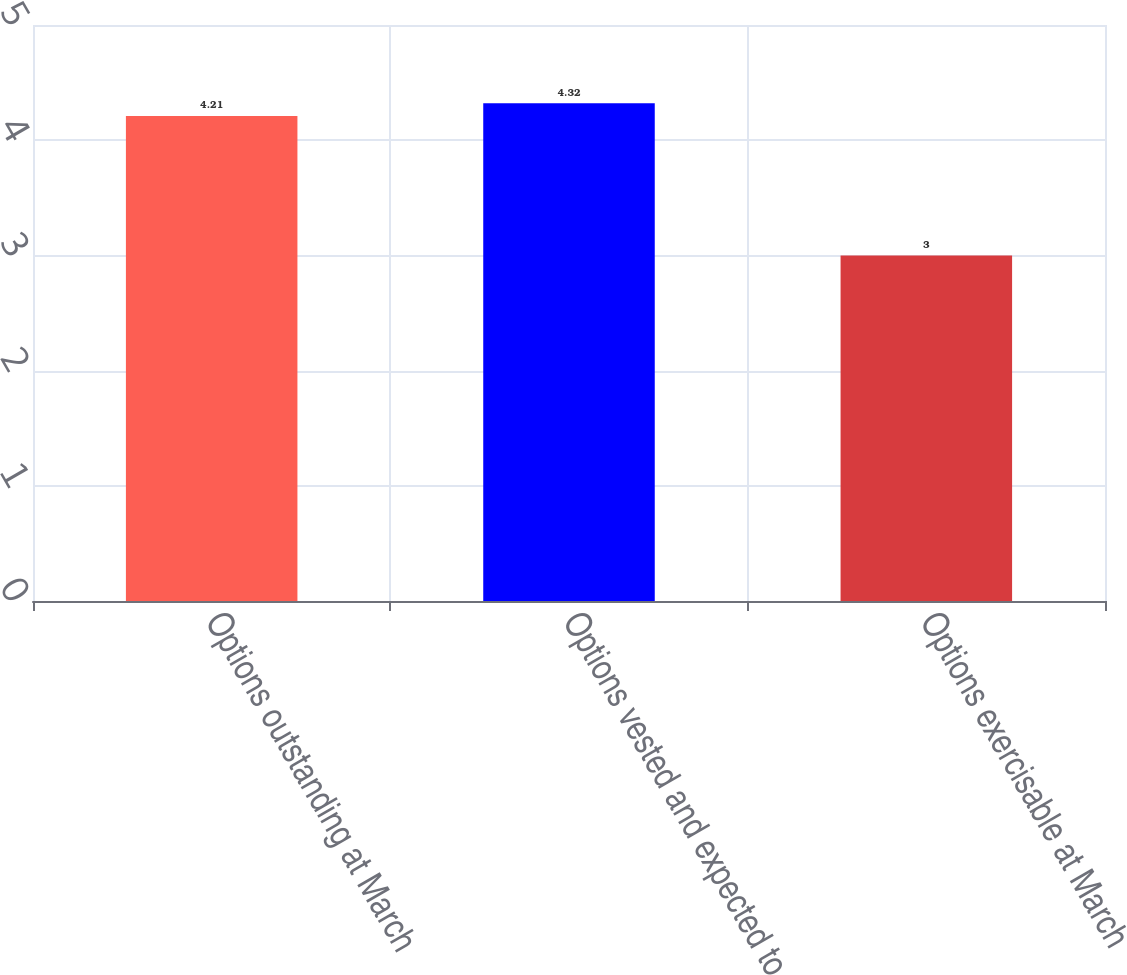Convert chart. <chart><loc_0><loc_0><loc_500><loc_500><bar_chart><fcel>Options outstanding at March<fcel>Options vested and expected to<fcel>Options exercisable at March<nl><fcel>4.21<fcel>4.32<fcel>3<nl></chart> 